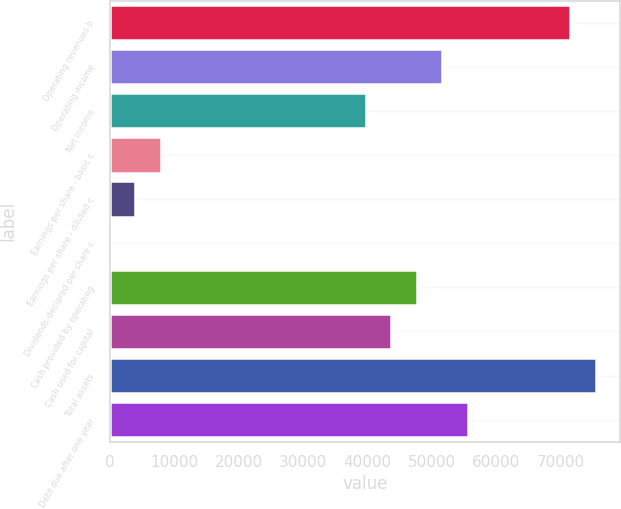Convert chart to OTSL. <chart><loc_0><loc_0><loc_500><loc_500><bar_chart><fcel>Operating revenues b<fcel>Operating income<fcel>Net income<fcel>Earnings per share - basic c<fcel>Earnings per share - diluted c<fcel>Dividends declared per share c<fcel>Cash provided by operating<fcel>Cash used for capital<fcel>Total assets<fcel>Debt due after one year<nl><fcel>71498.8<fcel>51638.3<fcel>39722<fcel>7945.18<fcel>3973.08<fcel>0.98<fcel>47666.2<fcel>43694.1<fcel>75470.9<fcel>55610.4<nl></chart> 